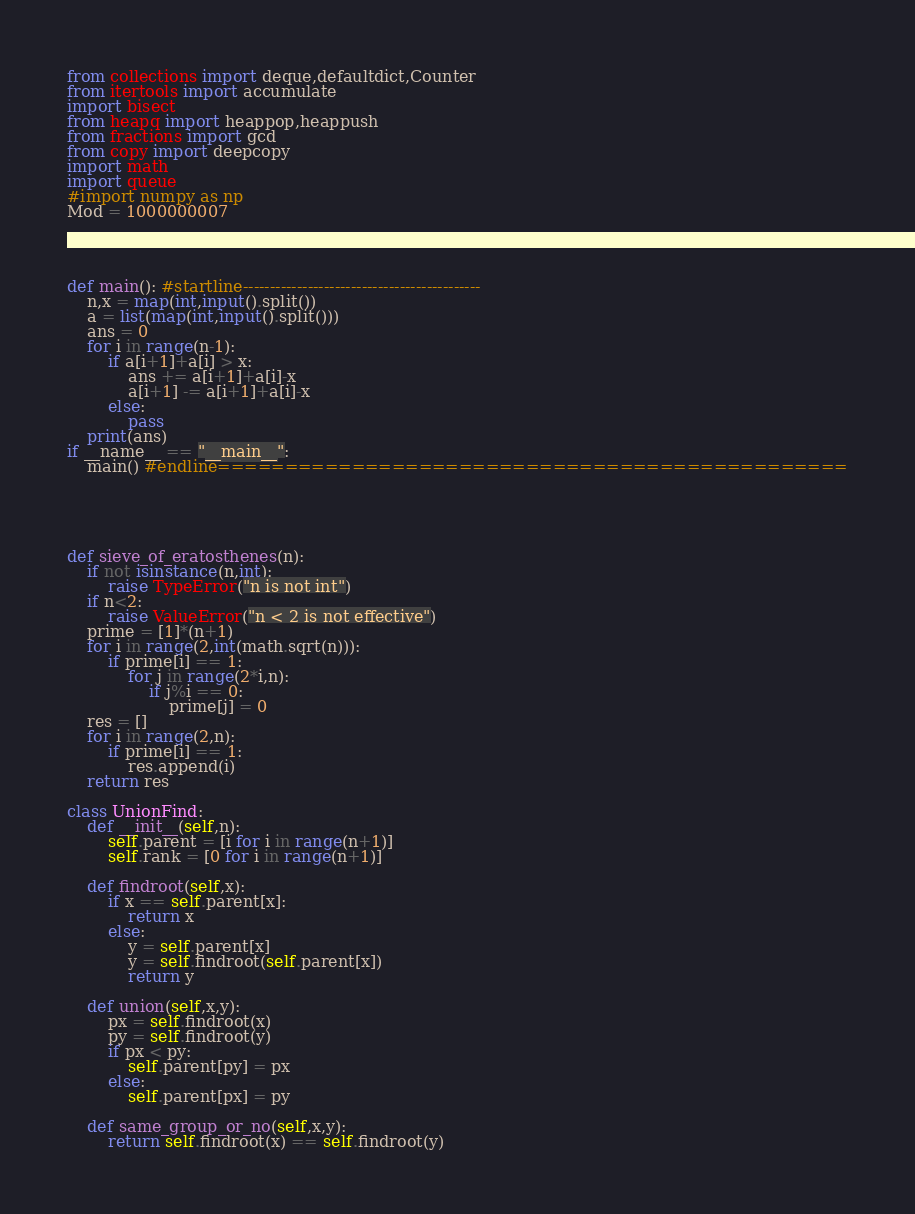<code> <loc_0><loc_0><loc_500><loc_500><_Python_>from collections import deque,defaultdict,Counter
from itertools import accumulate
import bisect
from heapq import heappop,heappush
from fractions import gcd
from copy import deepcopy
import math
import queue
#import numpy as np
Mod = 1000000007




def main(): #startline--------------------------------------------
    n,x = map(int,input().split())
    a = list(map(int,input().split()))
    ans = 0
    for i in range(n-1):
        if a[i+1]+a[i] > x:
            ans += a[i+1]+a[i]-x
            a[i+1] -= a[i+1]+a[i]-x
        else:
            pass
    print(ans) 
if __name__ == "__main__":
    main() #endline===============================================





def sieve_of_eratosthenes(n):
    if not isinstance(n,int):
        raise TypeError("n is not int")
    if n<2:
        raise ValueError("n < 2 is not effective")
    prime = [1]*(n+1)
    for i in range(2,int(math.sqrt(n))):
        if prime[i] == 1:
            for j in range(2*i,n):
                if j%i == 0:
                    prime[j] = 0
    res = []
    for i in range(2,n):
        if prime[i] == 1:
            res.append(i)
    return res

class UnionFind:
    def __init__(self,n):
        self.parent = [i for i in range(n+1)]
        self.rank = [0 for i in range(n+1)]
    
    def findroot(self,x):
        if x == self.parent[x]:
            return x
        else:
            y = self.parent[x]
            y = self.findroot(self.parent[x])
            return y
    
    def union(self,x,y):
        px = self.findroot(x)
        py = self.findroot(y)
        if px < py:
            self.parent[py] = px
        else:
            self.parent[px] = py

    def same_group_or_no(self,x,y):
        return self.findroot(x) == self.findroot(y)</code> 